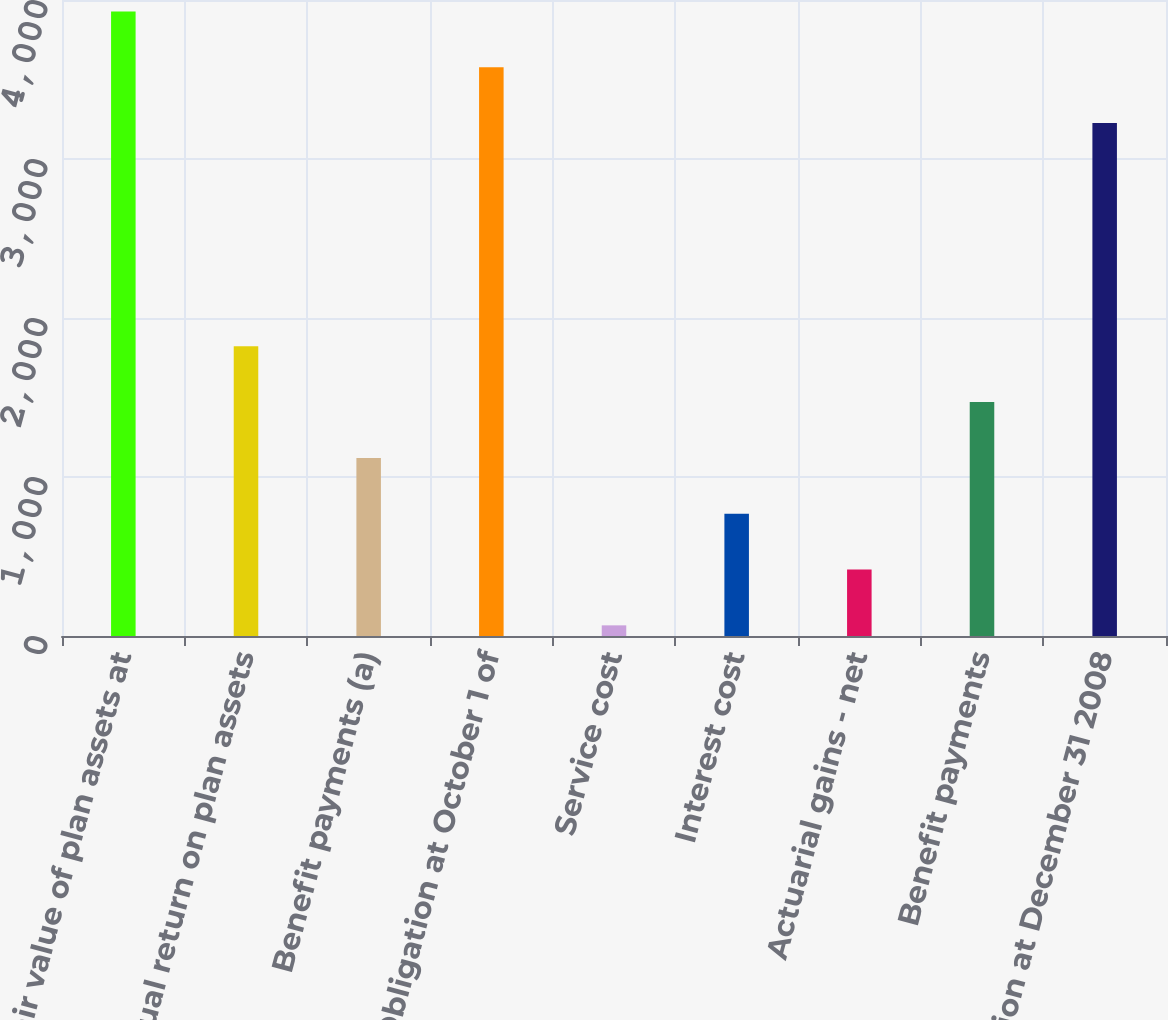Convert chart. <chart><loc_0><loc_0><loc_500><loc_500><bar_chart><fcel>Fair value of plan assets at<fcel>Actual return on plan assets<fcel>Benefit payments (a)<fcel>Obligation at October 1 of<fcel>Service cost<fcel>Interest cost<fcel>Actuarial gains - net<fcel>Benefit payments<fcel>Obligation at December 31 2008<nl><fcel>3928<fcel>1822<fcel>1120<fcel>3577<fcel>67<fcel>769<fcel>418<fcel>1471<fcel>3226<nl></chart> 